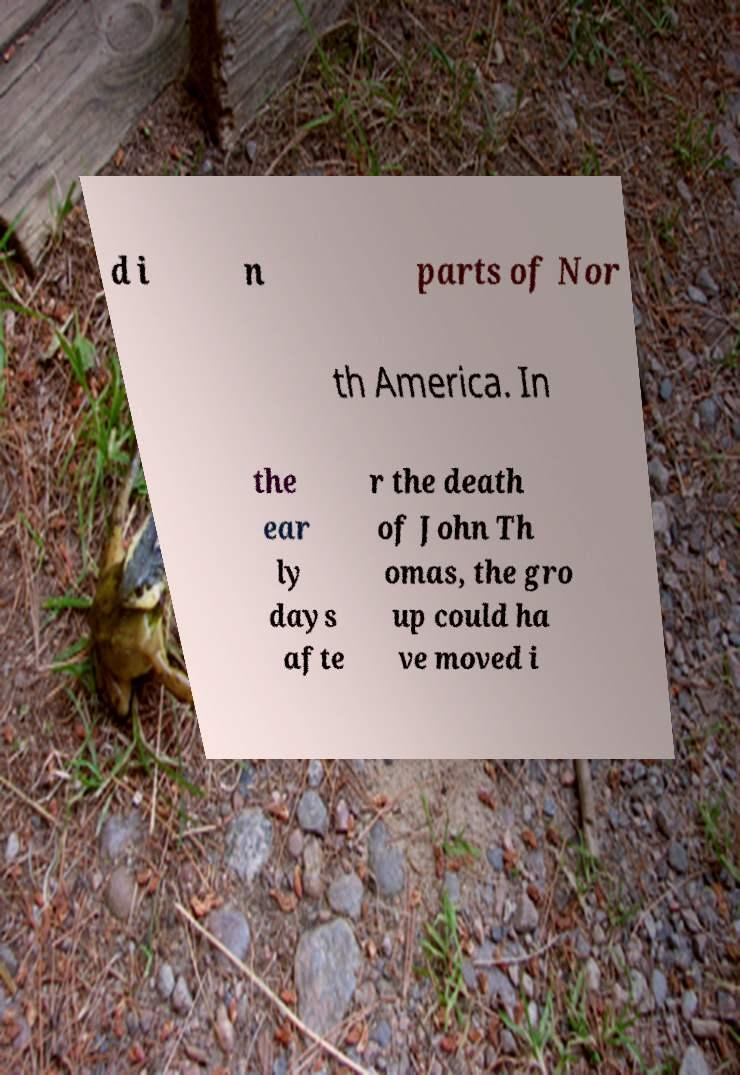Please read and relay the text visible in this image. What does it say? d i n parts of Nor th America. In the ear ly days afte r the death of John Th omas, the gro up could ha ve moved i 